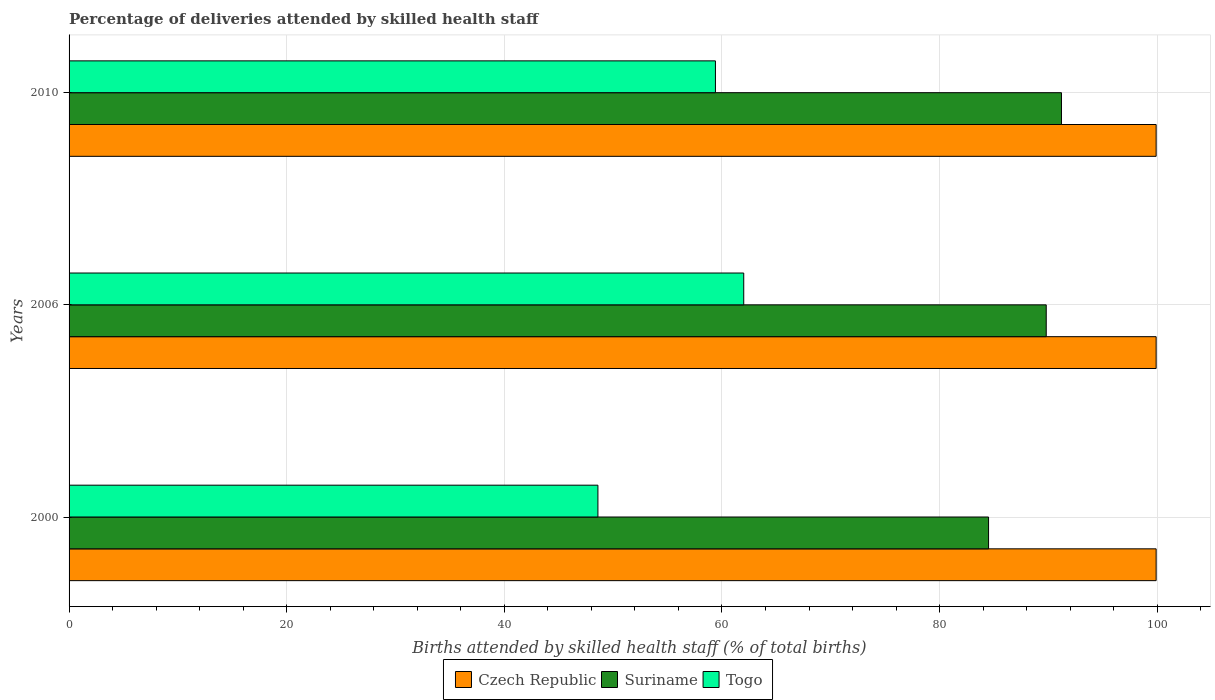How many different coloured bars are there?
Ensure brevity in your answer.  3. Are the number of bars per tick equal to the number of legend labels?
Ensure brevity in your answer.  Yes. Are the number of bars on each tick of the Y-axis equal?
Your answer should be compact. Yes. How many bars are there on the 1st tick from the top?
Keep it short and to the point. 3. In how many cases, is the number of bars for a given year not equal to the number of legend labels?
Make the answer very short. 0. Across all years, what is the maximum percentage of births attended by skilled health staff in Togo?
Provide a succinct answer. 62. Across all years, what is the minimum percentage of births attended by skilled health staff in Togo?
Offer a very short reply. 48.6. What is the total percentage of births attended by skilled health staff in Suriname in the graph?
Make the answer very short. 265.5. What is the difference between the percentage of births attended by skilled health staff in Togo in 2000 and that in 2006?
Keep it short and to the point. -13.4. What is the difference between the percentage of births attended by skilled health staff in Togo in 2010 and the percentage of births attended by skilled health staff in Suriname in 2000?
Keep it short and to the point. -25.1. What is the average percentage of births attended by skilled health staff in Togo per year?
Make the answer very short. 56.67. In the year 2000, what is the difference between the percentage of births attended by skilled health staff in Suriname and percentage of births attended by skilled health staff in Togo?
Provide a short and direct response. 35.9. What is the ratio of the percentage of births attended by skilled health staff in Czech Republic in 2000 to that in 2006?
Make the answer very short. 1. Is the difference between the percentage of births attended by skilled health staff in Suriname in 2000 and 2006 greater than the difference between the percentage of births attended by skilled health staff in Togo in 2000 and 2006?
Offer a very short reply. Yes. What is the difference between the highest and the second highest percentage of births attended by skilled health staff in Togo?
Your answer should be very brief. 2.6. What is the difference between the highest and the lowest percentage of births attended by skilled health staff in Togo?
Provide a succinct answer. 13.4. In how many years, is the percentage of births attended by skilled health staff in Suriname greater than the average percentage of births attended by skilled health staff in Suriname taken over all years?
Keep it short and to the point. 2. What does the 2nd bar from the top in 2006 represents?
Make the answer very short. Suriname. What does the 3rd bar from the bottom in 2000 represents?
Provide a short and direct response. Togo. Is it the case that in every year, the sum of the percentage of births attended by skilled health staff in Togo and percentage of births attended by skilled health staff in Czech Republic is greater than the percentage of births attended by skilled health staff in Suriname?
Offer a terse response. Yes. What is the difference between two consecutive major ticks on the X-axis?
Your response must be concise. 20. How are the legend labels stacked?
Make the answer very short. Horizontal. What is the title of the graph?
Offer a very short reply. Percentage of deliveries attended by skilled health staff. Does "Qatar" appear as one of the legend labels in the graph?
Make the answer very short. No. What is the label or title of the X-axis?
Make the answer very short. Births attended by skilled health staff (% of total births). What is the label or title of the Y-axis?
Provide a succinct answer. Years. What is the Births attended by skilled health staff (% of total births) of Czech Republic in 2000?
Make the answer very short. 99.9. What is the Births attended by skilled health staff (% of total births) of Suriname in 2000?
Make the answer very short. 84.5. What is the Births attended by skilled health staff (% of total births) of Togo in 2000?
Provide a short and direct response. 48.6. What is the Births attended by skilled health staff (% of total births) in Czech Republic in 2006?
Offer a very short reply. 99.9. What is the Births attended by skilled health staff (% of total births) of Suriname in 2006?
Offer a terse response. 89.8. What is the Births attended by skilled health staff (% of total births) of Togo in 2006?
Offer a terse response. 62. What is the Births attended by skilled health staff (% of total births) in Czech Republic in 2010?
Your answer should be compact. 99.9. What is the Births attended by skilled health staff (% of total births) in Suriname in 2010?
Make the answer very short. 91.2. What is the Births attended by skilled health staff (% of total births) in Togo in 2010?
Ensure brevity in your answer.  59.4. Across all years, what is the maximum Births attended by skilled health staff (% of total births) in Czech Republic?
Ensure brevity in your answer.  99.9. Across all years, what is the maximum Births attended by skilled health staff (% of total births) of Suriname?
Offer a terse response. 91.2. Across all years, what is the maximum Births attended by skilled health staff (% of total births) of Togo?
Provide a short and direct response. 62. Across all years, what is the minimum Births attended by skilled health staff (% of total births) in Czech Republic?
Keep it short and to the point. 99.9. Across all years, what is the minimum Births attended by skilled health staff (% of total births) of Suriname?
Keep it short and to the point. 84.5. Across all years, what is the minimum Births attended by skilled health staff (% of total births) of Togo?
Ensure brevity in your answer.  48.6. What is the total Births attended by skilled health staff (% of total births) of Czech Republic in the graph?
Provide a short and direct response. 299.7. What is the total Births attended by skilled health staff (% of total births) in Suriname in the graph?
Give a very brief answer. 265.5. What is the total Births attended by skilled health staff (% of total births) in Togo in the graph?
Your response must be concise. 170. What is the difference between the Births attended by skilled health staff (% of total births) in Czech Republic in 2000 and that in 2010?
Your answer should be very brief. 0. What is the difference between the Births attended by skilled health staff (% of total births) of Togo in 2000 and that in 2010?
Your answer should be very brief. -10.8. What is the difference between the Births attended by skilled health staff (% of total births) in Czech Republic in 2006 and that in 2010?
Your response must be concise. 0. What is the difference between the Births attended by skilled health staff (% of total births) in Suriname in 2006 and that in 2010?
Your response must be concise. -1.4. What is the difference between the Births attended by skilled health staff (% of total births) of Czech Republic in 2000 and the Births attended by skilled health staff (% of total births) of Togo in 2006?
Your response must be concise. 37.9. What is the difference between the Births attended by skilled health staff (% of total births) of Czech Republic in 2000 and the Births attended by skilled health staff (% of total births) of Togo in 2010?
Keep it short and to the point. 40.5. What is the difference between the Births attended by skilled health staff (% of total births) in Suriname in 2000 and the Births attended by skilled health staff (% of total births) in Togo in 2010?
Your answer should be compact. 25.1. What is the difference between the Births attended by skilled health staff (% of total births) in Czech Republic in 2006 and the Births attended by skilled health staff (% of total births) in Suriname in 2010?
Your answer should be very brief. 8.7. What is the difference between the Births attended by skilled health staff (% of total births) in Czech Republic in 2006 and the Births attended by skilled health staff (% of total births) in Togo in 2010?
Provide a succinct answer. 40.5. What is the difference between the Births attended by skilled health staff (% of total births) of Suriname in 2006 and the Births attended by skilled health staff (% of total births) of Togo in 2010?
Keep it short and to the point. 30.4. What is the average Births attended by skilled health staff (% of total births) in Czech Republic per year?
Your response must be concise. 99.9. What is the average Births attended by skilled health staff (% of total births) of Suriname per year?
Keep it short and to the point. 88.5. What is the average Births attended by skilled health staff (% of total births) of Togo per year?
Your answer should be compact. 56.67. In the year 2000, what is the difference between the Births attended by skilled health staff (% of total births) of Czech Republic and Births attended by skilled health staff (% of total births) of Togo?
Give a very brief answer. 51.3. In the year 2000, what is the difference between the Births attended by skilled health staff (% of total births) of Suriname and Births attended by skilled health staff (% of total births) of Togo?
Your answer should be compact. 35.9. In the year 2006, what is the difference between the Births attended by skilled health staff (% of total births) of Czech Republic and Births attended by skilled health staff (% of total births) of Suriname?
Ensure brevity in your answer.  10.1. In the year 2006, what is the difference between the Births attended by skilled health staff (% of total births) of Czech Republic and Births attended by skilled health staff (% of total births) of Togo?
Your answer should be very brief. 37.9. In the year 2006, what is the difference between the Births attended by skilled health staff (% of total births) in Suriname and Births attended by skilled health staff (% of total births) in Togo?
Your answer should be very brief. 27.8. In the year 2010, what is the difference between the Births attended by skilled health staff (% of total births) of Czech Republic and Births attended by skilled health staff (% of total births) of Togo?
Provide a succinct answer. 40.5. In the year 2010, what is the difference between the Births attended by skilled health staff (% of total births) in Suriname and Births attended by skilled health staff (% of total births) in Togo?
Keep it short and to the point. 31.8. What is the ratio of the Births attended by skilled health staff (% of total births) of Suriname in 2000 to that in 2006?
Provide a succinct answer. 0.94. What is the ratio of the Births attended by skilled health staff (% of total births) in Togo in 2000 to that in 2006?
Provide a succinct answer. 0.78. What is the ratio of the Births attended by skilled health staff (% of total births) in Czech Republic in 2000 to that in 2010?
Your response must be concise. 1. What is the ratio of the Births attended by skilled health staff (% of total births) in Suriname in 2000 to that in 2010?
Make the answer very short. 0.93. What is the ratio of the Births attended by skilled health staff (% of total births) in Togo in 2000 to that in 2010?
Provide a succinct answer. 0.82. What is the ratio of the Births attended by skilled health staff (% of total births) of Suriname in 2006 to that in 2010?
Provide a succinct answer. 0.98. What is the ratio of the Births attended by skilled health staff (% of total births) of Togo in 2006 to that in 2010?
Offer a very short reply. 1.04. What is the difference between the highest and the second highest Births attended by skilled health staff (% of total births) in Togo?
Give a very brief answer. 2.6. What is the difference between the highest and the lowest Births attended by skilled health staff (% of total births) in Togo?
Offer a very short reply. 13.4. 